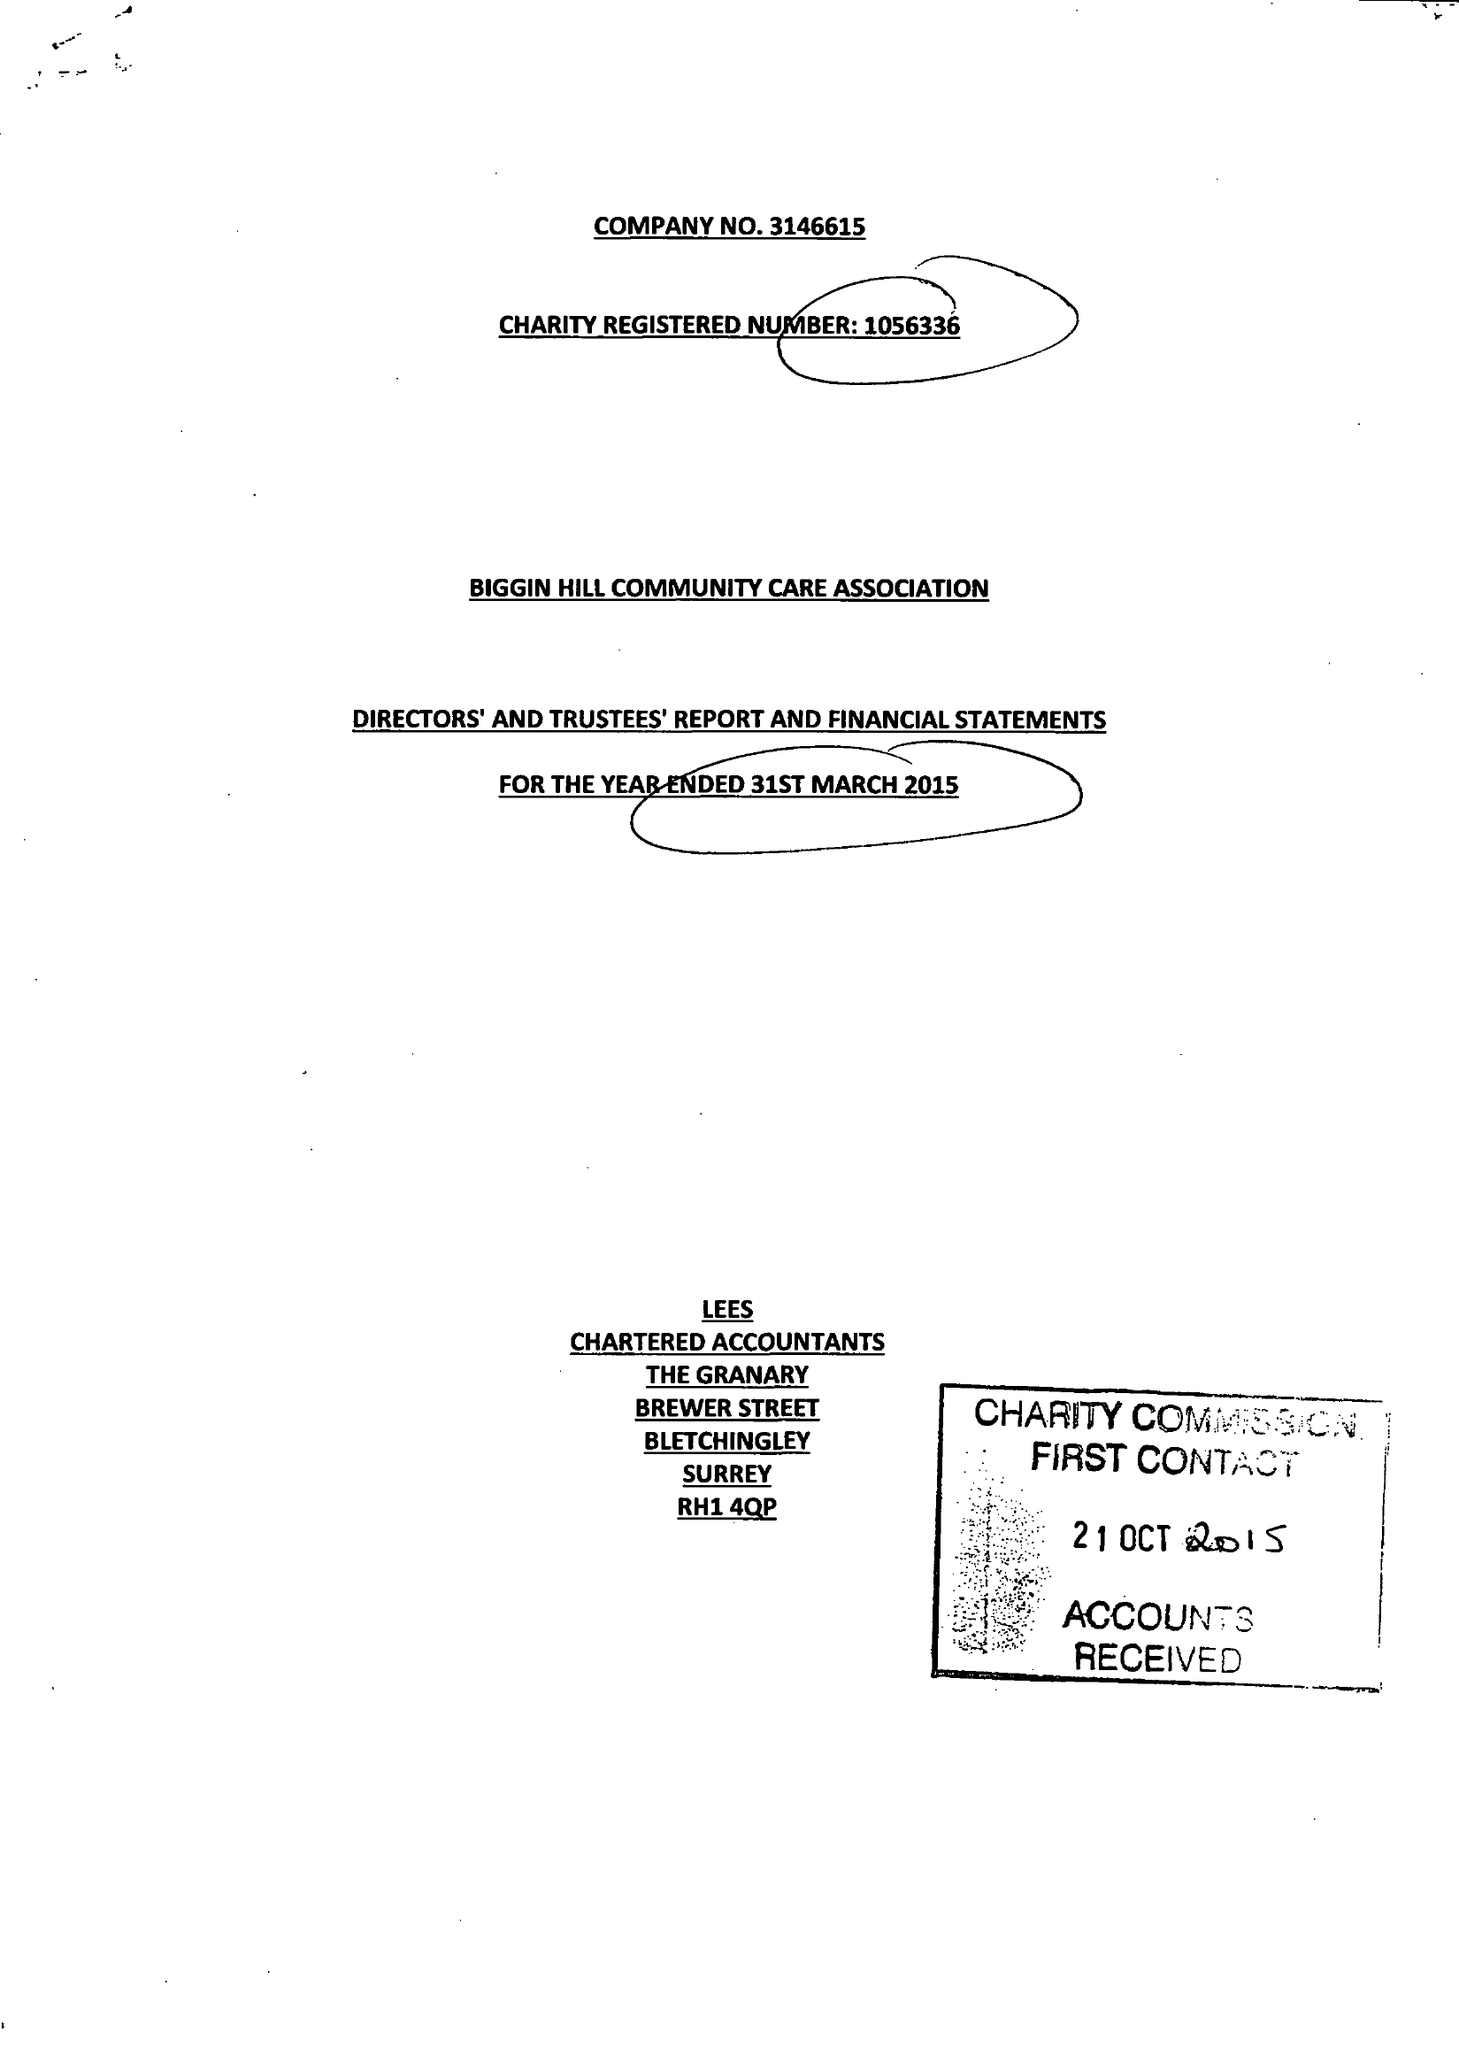What is the value for the address__post_town?
Answer the question using a single word or phrase. WESTERHAM 